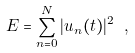Convert formula to latex. <formula><loc_0><loc_0><loc_500><loc_500>E = \sum _ { n = 0 } ^ { N } | u _ { n } ( t ) | ^ { 2 } \ ,</formula> 